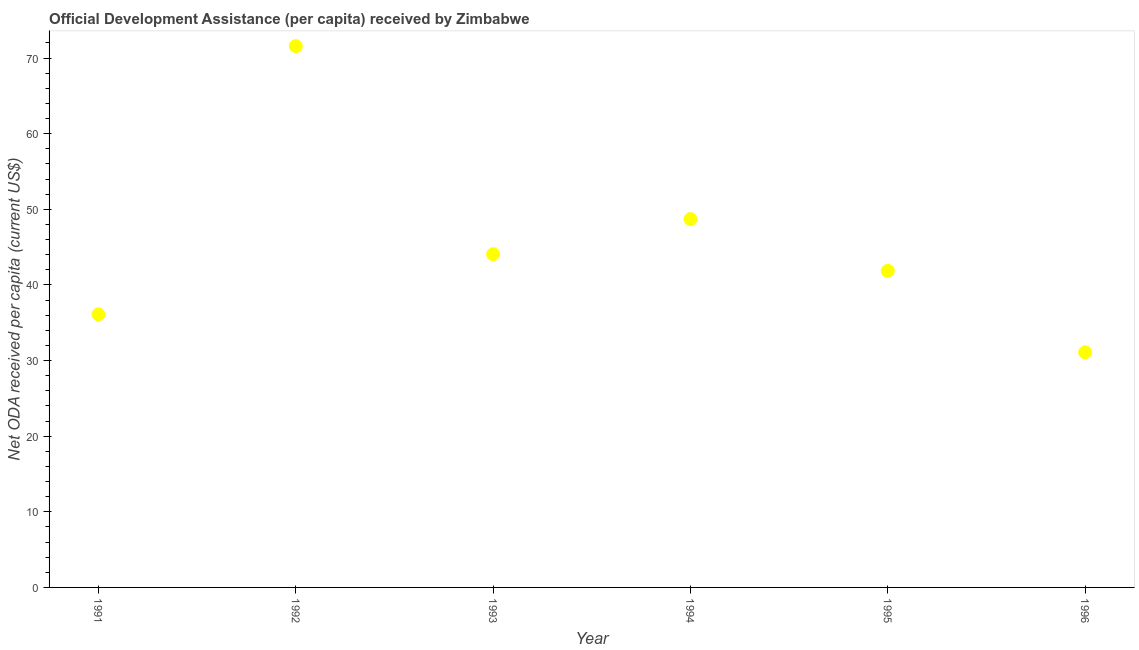What is the net oda received per capita in 1992?
Keep it short and to the point. 71.58. Across all years, what is the maximum net oda received per capita?
Provide a short and direct response. 71.58. Across all years, what is the minimum net oda received per capita?
Ensure brevity in your answer.  31.1. What is the sum of the net oda received per capita?
Offer a terse response. 273.43. What is the difference between the net oda received per capita in 1992 and 1995?
Your answer should be compact. 29.72. What is the average net oda received per capita per year?
Your answer should be compact. 45.57. What is the median net oda received per capita?
Provide a short and direct response. 42.97. Do a majority of the years between 1993 and 1991 (inclusive) have net oda received per capita greater than 4 US$?
Ensure brevity in your answer.  No. What is the ratio of the net oda received per capita in 1993 to that in 1995?
Offer a terse response. 1.05. Is the net oda received per capita in 1991 less than that in 1992?
Provide a short and direct response. Yes. What is the difference between the highest and the second highest net oda received per capita?
Give a very brief answer. 22.87. Is the sum of the net oda received per capita in 1994 and 1995 greater than the maximum net oda received per capita across all years?
Provide a succinct answer. Yes. What is the difference between the highest and the lowest net oda received per capita?
Give a very brief answer. 40.48. What is the difference between two consecutive major ticks on the Y-axis?
Keep it short and to the point. 10. Are the values on the major ticks of Y-axis written in scientific E-notation?
Ensure brevity in your answer.  No. Does the graph contain any zero values?
Make the answer very short. No. What is the title of the graph?
Keep it short and to the point. Official Development Assistance (per capita) received by Zimbabwe. What is the label or title of the Y-axis?
Provide a short and direct response. Net ODA received per capita (current US$). What is the Net ODA received per capita (current US$) in 1991?
Your answer should be compact. 36.11. What is the Net ODA received per capita (current US$) in 1992?
Your answer should be very brief. 71.58. What is the Net ODA received per capita (current US$) in 1993?
Make the answer very short. 44.07. What is the Net ODA received per capita (current US$) in 1994?
Your response must be concise. 48.71. What is the Net ODA received per capita (current US$) in 1995?
Offer a very short reply. 41.86. What is the Net ODA received per capita (current US$) in 1996?
Provide a short and direct response. 31.1. What is the difference between the Net ODA received per capita (current US$) in 1991 and 1992?
Offer a very short reply. -35.47. What is the difference between the Net ODA received per capita (current US$) in 1991 and 1993?
Ensure brevity in your answer.  -7.96. What is the difference between the Net ODA received per capita (current US$) in 1991 and 1994?
Your response must be concise. -12.59. What is the difference between the Net ODA received per capita (current US$) in 1991 and 1995?
Give a very brief answer. -5.75. What is the difference between the Net ODA received per capita (current US$) in 1991 and 1996?
Provide a short and direct response. 5.02. What is the difference between the Net ODA received per capita (current US$) in 1992 and 1993?
Your answer should be very brief. 27.51. What is the difference between the Net ODA received per capita (current US$) in 1992 and 1994?
Keep it short and to the point. 22.87. What is the difference between the Net ODA received per capita (current US$) in 1992 and 1995?
Keep it short and to the point. 29.72. What is the difference between the Net ODA received per capita (current US$) in 1992 and 1996?
Offer a terse response. 40.48. What is the difference between the Net ODA received per capita (current US$) in 1993 and 1994?
Ensure brevity in your answer.  -4.64. What is the difference between the Net ODA received per capita (current US$) in 1993 and 1995?
Keep it short and to the point. 2.2. What is the difference between the Net ODA received per capita (current US$) in 1993 and 1996?
Ensure brevity in your answer.  12.97. What is the difference between the Net ODA received per capita (current US$) in 1994 and 1995?
Offer a terse response. 6.84. What is the difference between the Net ODA received per capita (current US$) in 1994 and 1996?
Offer a very short reply. 17.61. What is the difference between the Net ODA received per capita (current US$) in 1995 and 1996?
Give a very brief answer. 10.77. What is the ratio of the Net ODA received per capita (current US$) in 1991 to that in 1992?
Your answer should be compact. 0.51. What is the ratio of the Net ODA received per capita (current US$) in 1991 to that in 1993?
Provide a succinct answer. 0.82. What is the ratio of the Net ODA received per capita (current US$) in 1991 to that in 1994?
Make the answer very short. 0.74. What is the ratio of the Net ODA received per capita (current US$) in 1991 to that in 1995?
Your answer should be compact. 0.86. What is the ratio of the Net ODA received per capita (current US$) in 1991 to that in 1996?
Ensure brevity in your answer.  1.16. What is the ratio of the Net ODA received per capita (current US$) in 1992 to that in 1993?
Offer a terse response. 1.62. What is the ratio of the Net ODA received per capita (current US$) in 1992 to that in 1994?
Offer a very short reply. 1.47. What is the ratio of the Net ODA received per capita (current US$) in 1992 to that in 1995?
Your answer should be very brief. 1.71. What is the ratio of the Net ODA received per capita (current US$) in 1992 to that in 1996?
Provide a succinct answer. 2.3. What is the ratio of the Net ODA received per capita (current US$) in 1993 to that in 1994?
Your answer should be compact. 0.91. What is the ratio of the Net ODA received per capita (current US$) in 1993 to that in 1995?
Offer a very short reply. 1.05. What is the ratio of the Net ODA received per capita (current US$) in 1993 to that in 1996?
Ensure brevity in your answer.  1.42. What is the ratio of the Net ODA received per capita (current US$) in 1994 to that in 1995?
Your answer should be very brief. 1.16. What is the ratio of the Net ODA received per capita (current US$) in 1994 to that in 1996?
Make the answer very short. 1.57. What is the ratio of the Net ODA received per capita (current US$) in 1995 to that in 1996?
Provide a short and direct response. 1.35. 